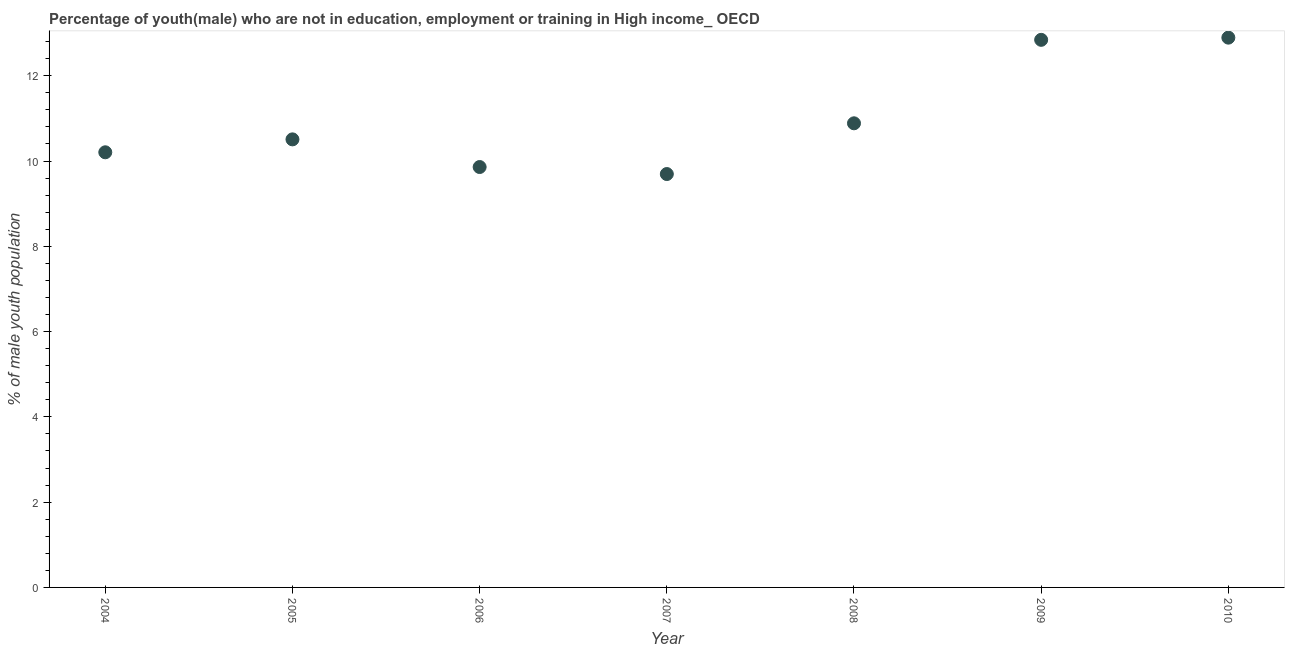What is the unemployed male youth population in 2010?
Make the answer very short. 12.89. Across all years, what is the maximum unemployed male youth population?
Your answer should be compact. 12.89. Across all years, what is the minimum unemployed male youth population?
Your response must be concise. 9.7. In which year was the unemployed male youth population maximum?
Ensure brevity in your answer.  2010. In which year was the unemployed male youth population minimum?
Keep it short and to the point. 2007. What is the sum of the unemployed male youth population?
Give a very brief answer. 76.89. What is the difference between the unemployed male youth population in 2008 and 2010?
Make the answer very short. -2.01. What is the average unemployed male youth population per year?
Your response must be concise. 10.98. What is the median unemployed male youth population?
Your answer should be very brief. 10.51. In how many years, is the unemployed male youth population greater than 3.6 %?
Offer a terse response. 7. What is the ratio of the unemployed male youth population in 2004 to that in 2005?
Provide a succinct answer. 0.97. Is the unemployed male youth population in 2007 less than that in 2009?
Your answer should be very brief. Yes. Is the difference between the unemployed male youth population in 2004 and 2006 greater than the difference between any two years?
Make the answer very short. No. What is the difference between the highest and the second highest unemployed male youth population?
Keep it short and to the point. 0.05. What is the difference between the highest and the lowest unemployed male youth population?
Make the answer very short. 3.2. In how many years, is the unemployed male youth population greater than the average unemployed male youth population taken over all years?
Your response must be concise. 2. Does the unemployed male youth population monotonically increase over the years?
Ensure brevity in your answer.  No. How many years are there in the graph?
Offer a very short reply. 7. Are the values on the major ticks of Y-axis written in scientific E-notation?
Your response must be concise. No. Does the graph contain grids?
Your response must be concise. No. What is the title of the graph?
Make the answer very short. Percentage of youth(male) who are not in education, employment or training in High income_ OECD. What is the label or title of the X-axis?
Ensure brevity in your answer.  Year. What is the label or title of the Y-axis?
Your answer should be compact. % of male youth population. What is the % of male youth population in 2004?
Your response must be concise. 10.21. What is the % of male youth population in 2005?
Your answer should be very brief. 10.51. What is the % of male youth population in 2006?
Your answer should be very brief. 9.86. What is the % of male youth population in 2007?
Your answer should be very brief. 9.7. What is the % of male youth population in 2008?
Offer a very short reply. 10.89. What is the % of male youth population in 2009?
Ensure brevity in your answer.  12.84. What is the % of male youth population in 2010?
Provide a short and direct response. 12.89. What is the difference between the % of male youth population in 2004 and 2005?
Provide a short and direct response. -0.3. What is the difference between the % of male youth population in 2004 and 2006?
Your answer should be compact. 0.35. What is the difference between the % of male youth population in 2004 and 2007?
Offer a terse response. 0.51. What is the difference between the % of male youth population in 2004 and 2008?
Your answer should be very brief. -0.68. What is the difference between the % of male youth population in 2004 and 2009?
Ensure brevity in your answer.  -2.64. What is the difference between the % of male youth population in 2004 and 2010?
Give a very brief answer. -2.69. What is the difference between the % of male youth population in 2005 and 2006?
Your answer should be compact. 0.65. What is the difference between the % of male youth population in 2005 and 2007?
Offer a terse response. 0.81. What is the difference between the % of male youth population in 2005 and 2008?
Offer a very short reply. -0.38. What is the difference between the % of male youth population in 2005 and 2009?
Your response must be concise. -2.33. What is the difference between the % of male youth population in 2005 and 2010?
Give a very brief answer. -2.39. What is the difference between the % of male youth population in 2006 and 2007?
Provide a short and direct response. 0.16. What is the difference between the % of male youth population in 2006 and 2008?
Offer a terse response. -1.03. What is the difference between the % of male youth population in 2006 and 2009?
Ensure brevity in your answer.  -2.98. What is the difference between the % of male youth population in 2006 and 2010?
Offer a very short reply. -3.03. What is the difference between the % of male youth population in 2007 and 2008?
Your response must be concise. -1.19. What is the difference between the % of male youth population in 2007 and 2009?
Keep it short and to the point. -3.15. What is the difference between the % of male youth population in 2007 and 2010?
Make the answer very short. -3.2. What is the difference between the % of male youth population in 2008 and 2009?
Your response must be concise. -1.96. What is the difference between the % of male youth population in 2008 and 2010?
Make the answer very short. -2.01. What is the difference between the % of male youth population in 2009 and 2010?
Offer a terse response. -0.05. What is the ratio of the % of male youth population in 2004 to that in 2005?
Your answer should be compact. 0.97. What is the ratio of the % of male youth population in 2004 to that in 2006?
Ensure brevity in your answer.  1.03. What is the ratio of the % of male youth population in 2004 to that in 2007?
Your answer should be compact. 1.05. What is the ratio of the % of male youth population in 2004 to that in 2008?
Make the answer very short. 0.94. What is the ratio of the % of male youth population in 2004 to that in 2009?
Keep it short and to the point. 0.8. What is the ratio of the % of male youth population in 2004 to that in 2010?
Offer a very short reply. 0.79. What is the ratio of the % of male youth population in 2005 to that in 2006?
Your answer should be compact. 1.07. What is the ratio of the % of male youth population in 2005 to that in 2007?
Keep it short and to the point. 1.08. What is the ratio of the % of male youth population in 2005 to that in 2009?
Provide a short and direct response. 0.82. What is the ratio of the % of male youth population in 2005 to that in 2010?
Make the answer very short. 0.81. What is the ratio of the % of male youth population in 2006 to that in 2007?
Provide a succinct answer. 1.02. What is the ratio of the % of male youth population in 2006 to that in 2008?
Provide a short and direct response. 0.91. What is the ratio of the % of male youth population in 2006 to that in 2009?
Provide a succinct answer. 0.77. What is the ratio of the % of male youth population in 2006 to that in 2010?
Your answer should be very brief. 0.77. What is the ratio of the % of male youth population in 2007 to that in 2008?
Give a very brief answer. 0.89. What is the ratio of the % of male youth population in 2007 to that in 2009?
Keep it short and to the point. 0.76. What is the ratio of the % of male youth population in 2007 to that in 2010?
Provide a short and direct response. 0.75. What is the ratio of the % of male youth population in 2008 to that in 2009?
Your answer should be very brief. 0.85. What is the ratio of the % of male youth population in 2008 to that in 2010?
Make the answer very short. 0.84. What is the ratio of the % of male youth population in 2009 to that in 2010?
Make the answer very short. 1. 